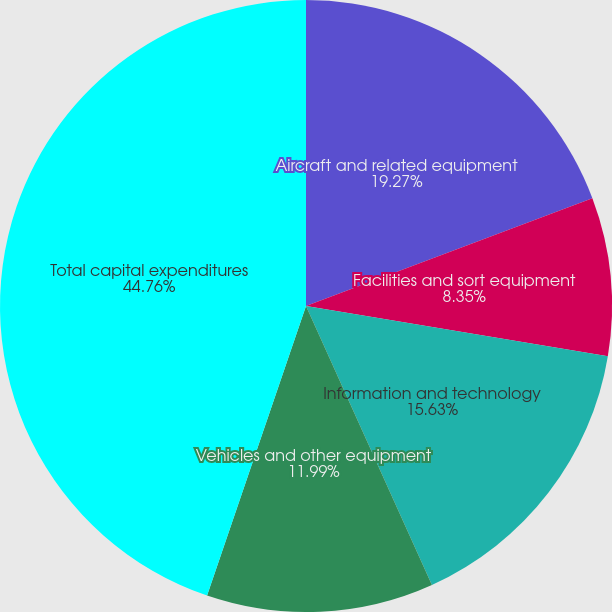Convert chart. <chart><loc_0><loc_0><loc_500><loc_500><pie_chart><fcel>Aircraft and related equipment<fcel>Facilities and sort equipment<fcel>Information and technology<fcel>Vehicles and other equipment<fcel>Total capital expenditures<nl><fcel>19.27%<fcel>8.35%<fcel>15.63%<fcel>11.99%<fcel>44.76%<nl></chart> 